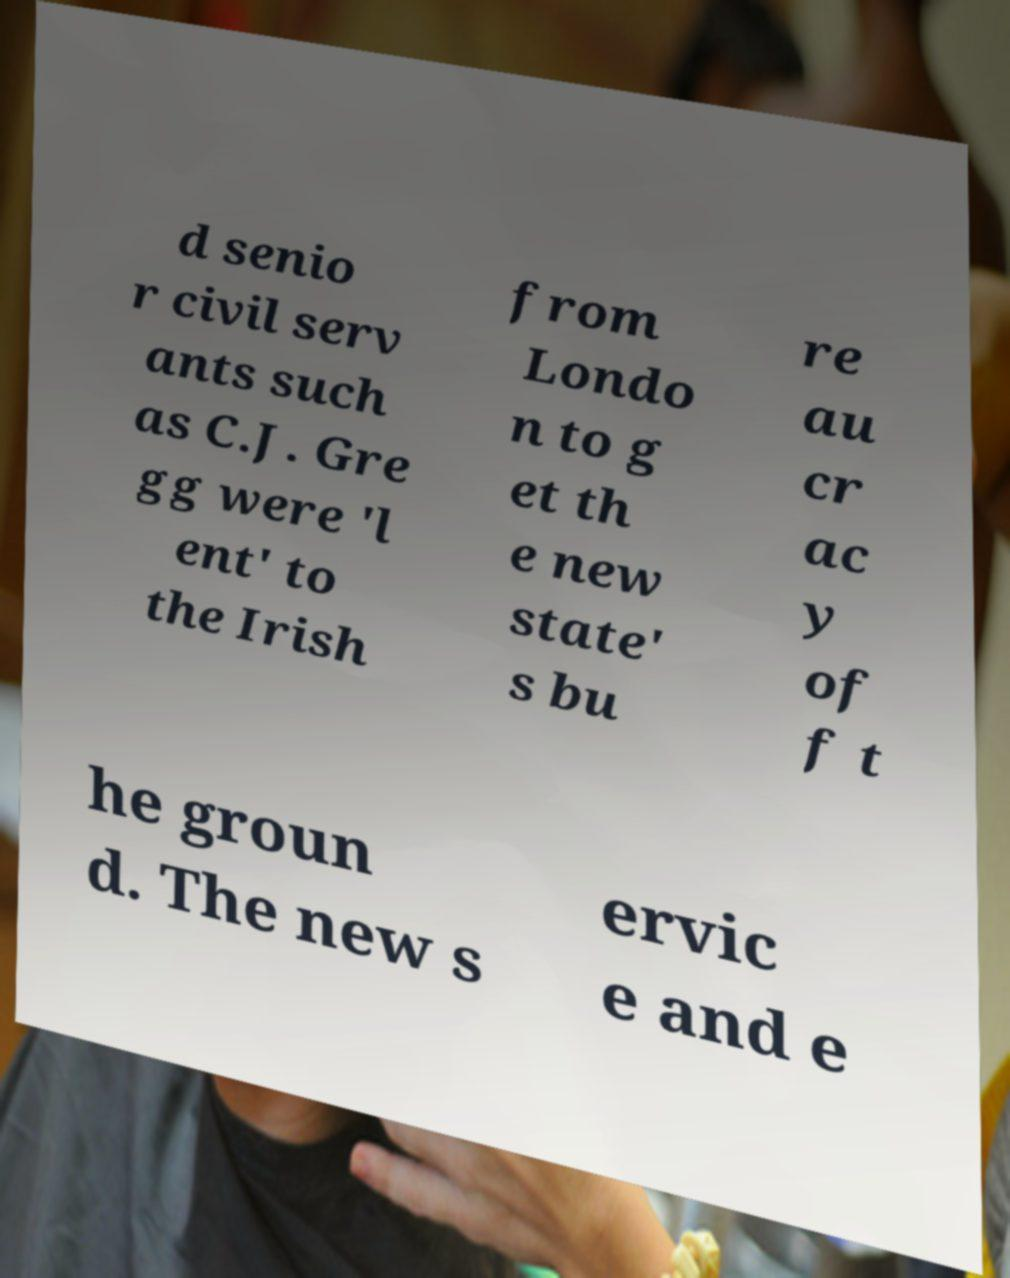Please identify and transcribe the text found in this image. d senio r civil serv ants such as C.J. Gre gg were 'l ent' to the Irish from Londo n to g et th e new state' s bu re au cr ac y of f t he groun d. The new s ervic e and e 